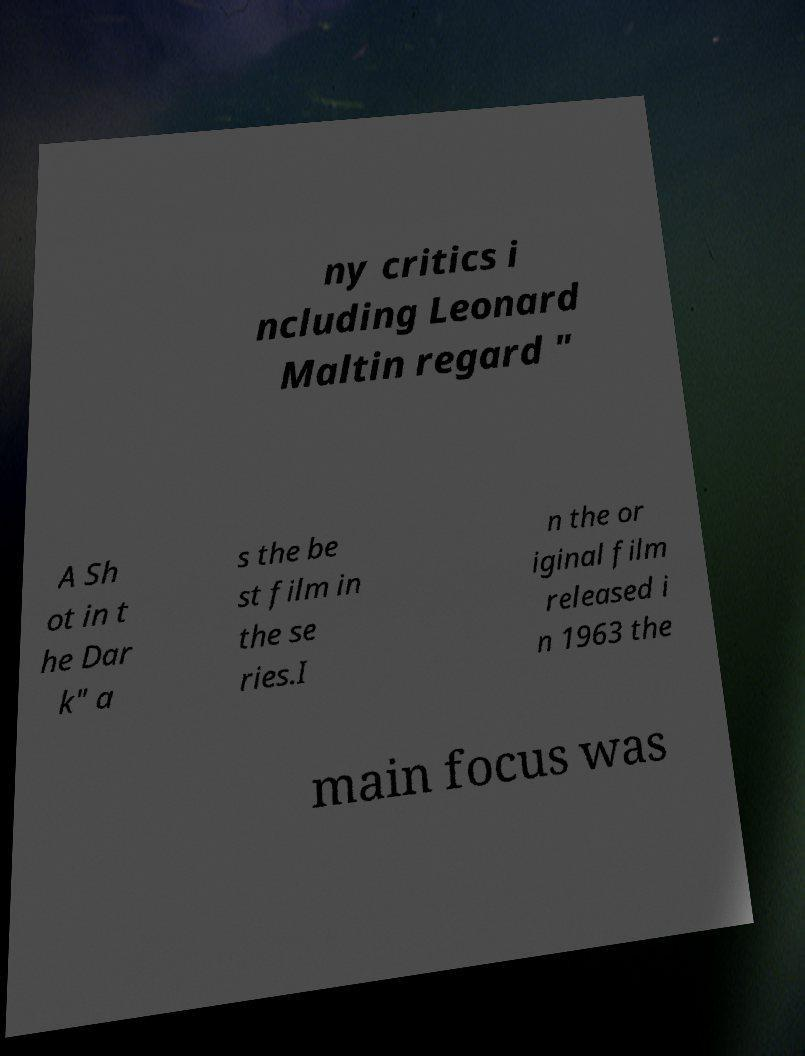What messages or text are displayed in this image? I need them in a readable, typed format. ny critics i ncluding Leonard Maltin regard " A Sh ot in t he Dar k" a s the be st film in the se ries.I n the or iginal film released i n 1963 the main focus was 